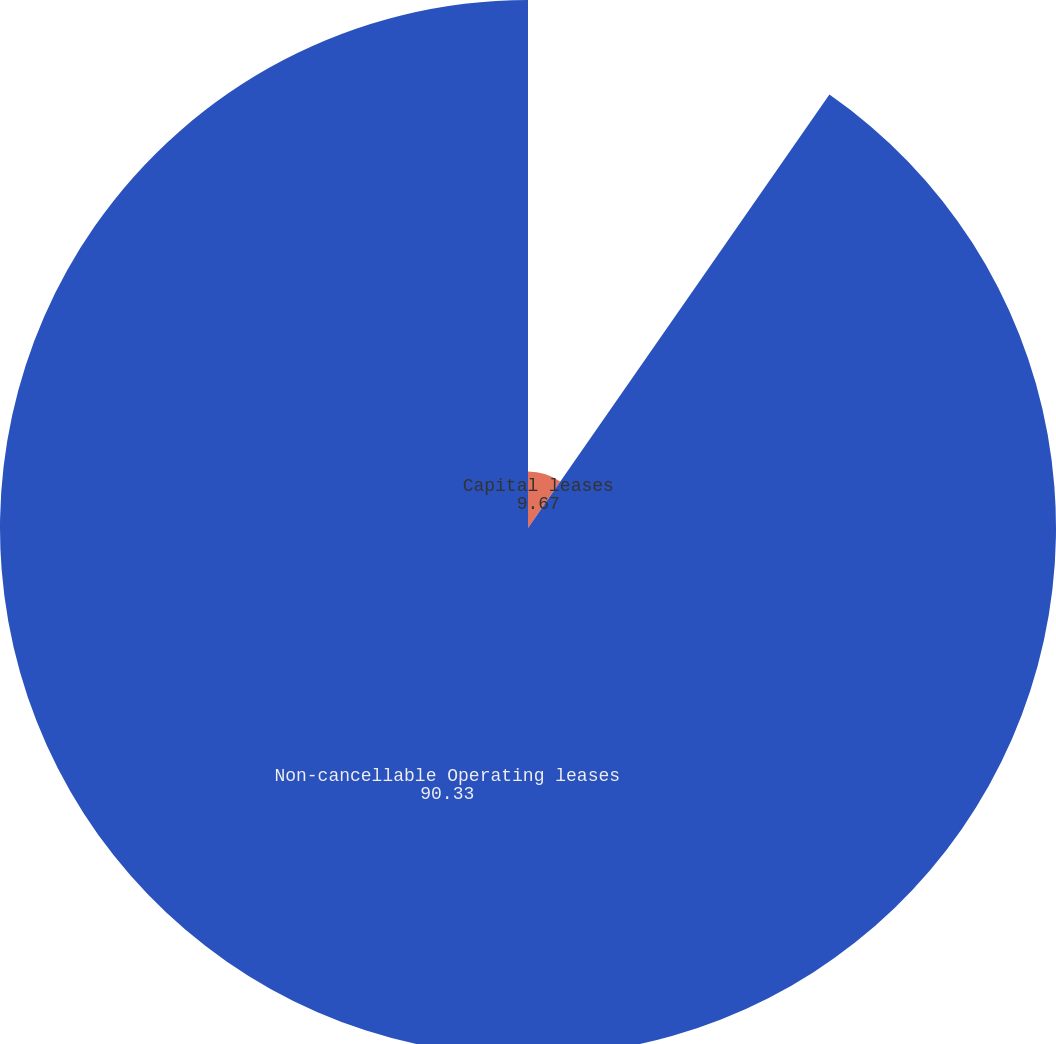Convert chart to OTSL. <chart><loc_0><loc_0><loc_500><loc_500><pie_chart><fcel>Capital leases<fcel>Non-cancellable Operating leases<nl><fcel>9.67%<fcel>90.33%<nl></chart> 